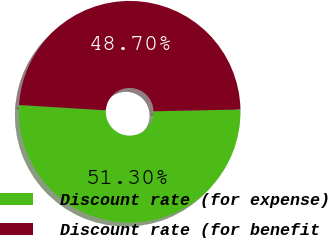Convert chart to OTSL. <chart><loc_0><loc_0><loc_500><loc_500><pie_chart><fcel>Discount rate (for expense)<fcel>Discount rate (for benefit<nl><fcel>51.3%<fcel>48.7%<nl></chart> 